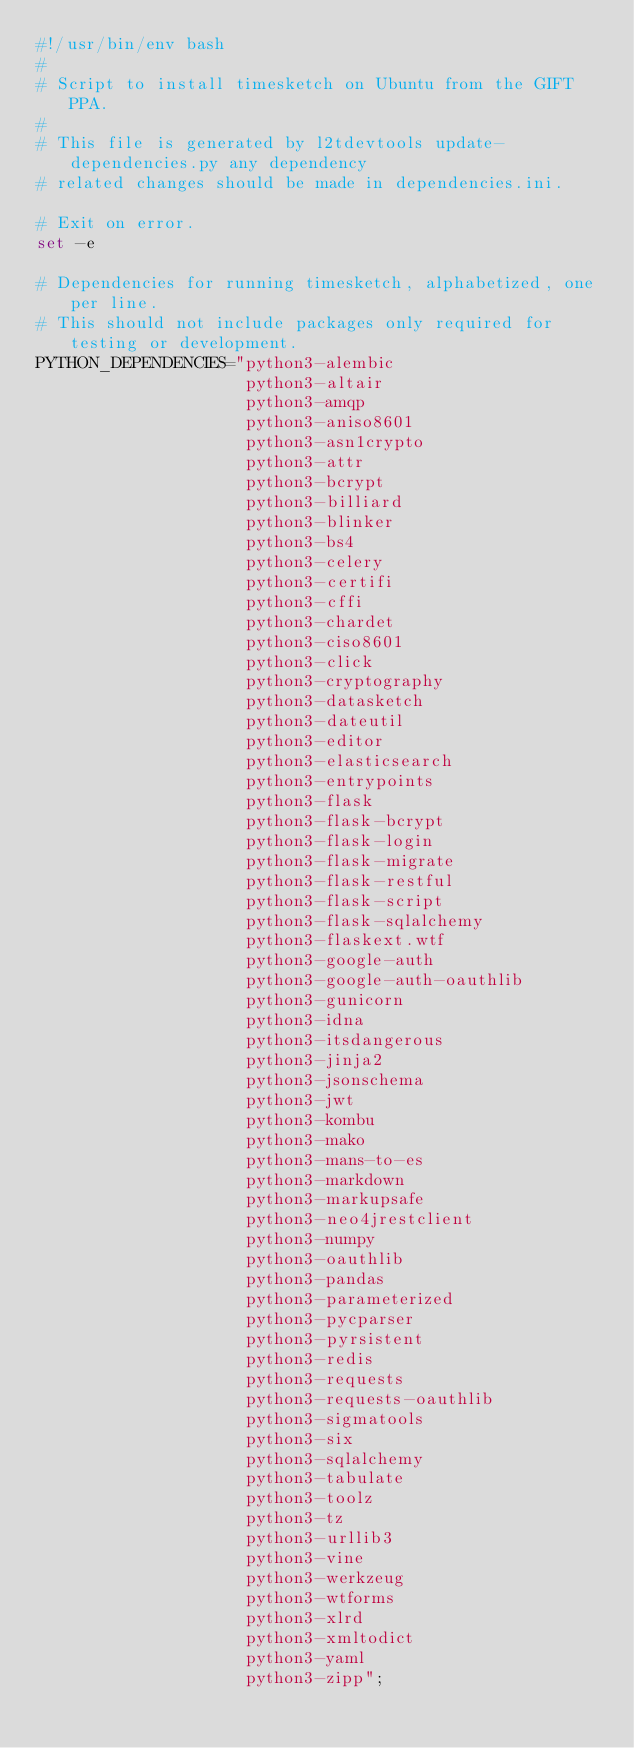<code> <loc_0><loc_0><loc_500><loc_500><_Bash_>#!/usr/bin/env bash
#
# Script to install timesketch on Ubuntu from the GIFT PPA.
#
# This file is generated by l2tdevtools update-dependencies.py any dependency
# related changes should be made in dependencies.ini.

# Exit on error.
set -e

# Dependencies for running timesketch, alphabetized, one per line.
# This should not include packages only required for testing or development.
PYTHON_DEPENDENCIES="python3-alembic
                     python3-altair
                     python3-amqp
                     python3-aniso8601
                     python3-asn1crypto
                     python3-attr
                     python3-bcrypt
                     python3-billiard
                     python3-blinker
                     python3-bs4
                     python3-celery
                     python3-certifi
                     python3-cffi
                     python3-chardet
                     python3-ciso8601
                     python3-click
                     python3-cryptography
                     python3-datasketch
                     python3-dateutil
                     python3-editor
                     python3-elasticsearch
                     python3-entrypoints
                     python3-flask
                     python3-flask-bcrypt
                     python3-flask-login
                     python3-flask-migrate
                     python3-flask-restful
                     python3-flask-script
                     python3-flask-sqlalchemy
                     python3-flaskext.wtf
                     python3-google-auth
                     python3-google-auth-oauthlib
                     python3-gunicorn
                     python3-idna
                     python3-itsdangerous
                     python3-jinja2
                     python3-jsonschema
                     python3-jwt
                     python3-kombu
                     python3-mako
                     python3-mans-to-es
                     python3-markdown
                     python3-markupsafe
                     python3-neo4jrestclient
                     python3-numpy
                     python3-oauthlib
                     python3-pandas
                     python3-parameterized
                     python3-pycparser
                     python3-pyrsistent
                     python3-redis
                     python3-requests
                     python3-requests-oauthlib
                     python3-sigmatools
                     python3-six
                     python3-sqlalchemy
                     python3-tabulate
                     python3-toolz
                     python3-tz
                     python3-urllib3
                     python3-vine
                     python3-werkzeug
                     python3-wtforms
                     python3-xlrd
                     python3-xmltodict
                     python3-yaml
                     python3-zipp";
</code> 